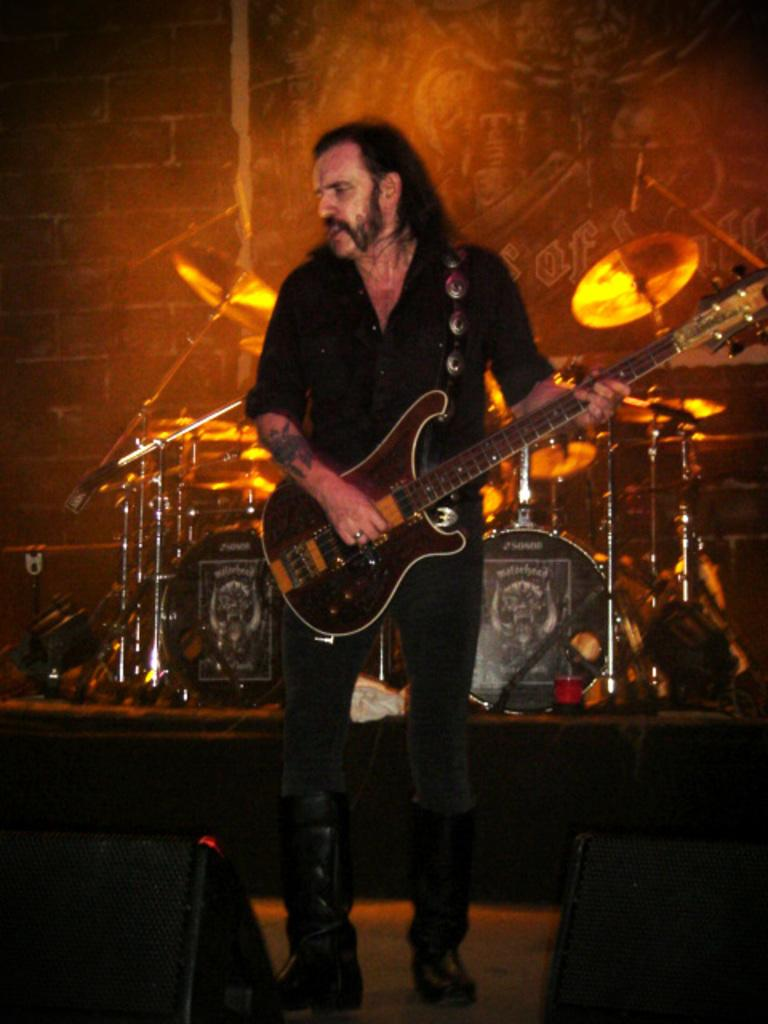What is the main subject of the image? The main subject of the image is a man. What is the man doing in the image? The man is standing and holding a guitar. What other musical instruments can be seen in the image? There are speakers, drums, and cymbals with cymbal stands in the background of the image. What is the setting of the image? There is a wall and focus lights in the background of the image, suggesting an indoor setting. What type of garden can be seen in the image? There is no garden present in the image; it features a man holding a guitar and other musical equipment in an indoor setting. What scientific theory is being discussed in the image? There is no discussion of a scientific theory in the image; it focuses on a man and musical instruments. 